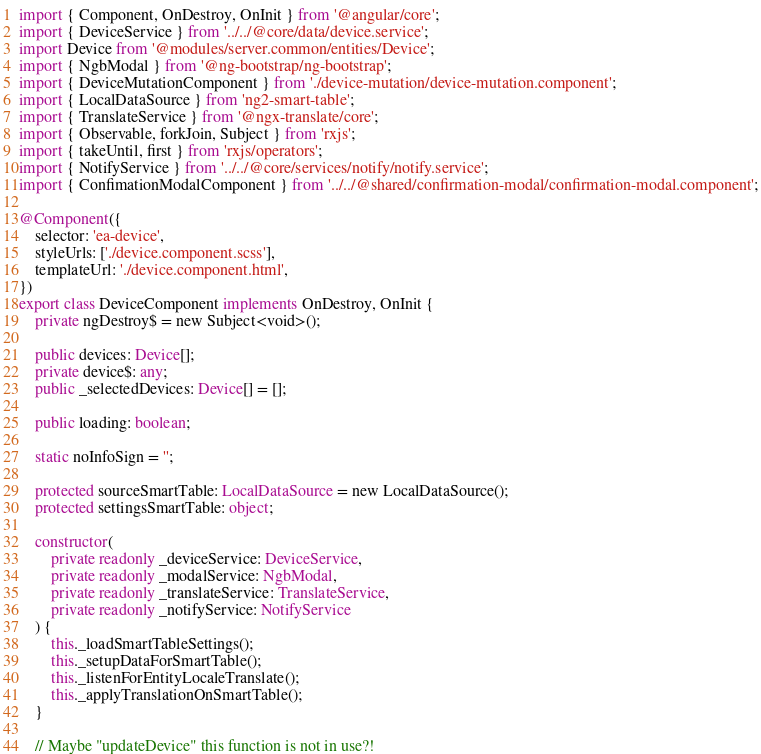<code> <loc_0><loc_0><loc_500><loc_500><_TypeScript_>import { Component, OnDestroy, OnInit } from '@angular/core';
import { DeviceService } from '../../@core/data/device.service';
import Device from '@modules/server.common/entities/Device';
import { NgbModal } from '@ng-bootstrap/ng-bootstrap';
import { DeviceMutationComponent } from './device-mutation/device-mutation.component';
import { LocalDataSource } from 'ng2-smart-table';
import { TranslateService } from '@ngx-translate/core';
import { Observable, forkJoin, Subject } from 'rxjs';
import { takeUntil, first } from 'rxjs/operators';
import { NotifyService } from '../../@core/services/notify/notify.service';
import { ConfimationModalComponent } from '../../@shared/confirmation-modal/confirmation-modal.component';

@Component({
	selector: 'ea-device',
	styleUrls: ['./device.component.scss'],
	templateUrl: './device.component.html',
})
export class DeviceComponent implements OnDestroy, OnInit {
	private ngDestroy$ = new Subject<void>();

	public devices: Device[];
	private device$: any;
	public _selectedDevices: Device[] = [];

	public loading: boolean;

	static noInfoSign = '';

	protected sourceSmartTable: LocalDataSource = new LocalDataSource();
	protected settingsSmartTable: object;

	constructor(
		private readonly _deviceService: DeviceService,
		private readonly _modalService: NgbModal,
		private readonly _translateService: TranslateService,
		private readonly _notifyService: NotifyService
	) {
		this._loadSmartTableSettings();
		this._setupDataForSmartTable();
		this._listenForEntityLocaleTranslate();
		this._applyTranslationOnSmartTable();
	}

	// Maybe "updateDevice" this function is not in use?!</code> 